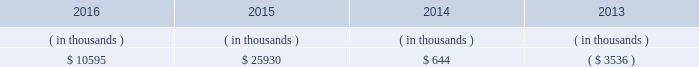Entergy mississippi , inc .
Management 2019s financial discussion and analysis entergy mississippi 2019s receivables from or ( payables to ) the money pool were as follows as of december 31 for each of the following years. .
See note 4 to the financial statements for a description of the money pool .
Entergy mississippi has four separate credit facilities in the aggregate amount of $ 102.5 million scheduled to expire may 2017 .
No borrowings were outstanding under the credit facilities as of december 31 , 2016 .
In addition , entergy mississippi is a party to an uncommitted letter of credit facility as a means to post collateral to support its obligations under miso .
As of december 31 , 2016 , a $ 7.1 million letter of credit was outstanding under entergy mississippi 2019s uncommitted letter of credit facility .
See note 4 to the financial statements for additional discussion of the credit facilities .
Entergy mississippi obtained authorizations from the ferc through october 2017 for short-term borrowings not to exceed an aggregate amount of $ 175 million at any time outstanding and long-term borrowings and security issuances .
See note 4 to the financial statements for further discussion of entergy mississippi 2019s short-term borrowing limits .
State and local rate regulation and fuel-cost recovery the rates that entergy mississippi charges for electricity significantly influence its financial position , results of operations , and liquidity .
Entergy mississippi is regulated and the rates charged to its customers are determined in regulatory proceedings .
A governmental agency , the mpsc , is primarily responsible for approval of the rates charged to customers .
Formula rate plan in june 2014 , entergy mississippi filed its first general rate case before the mpsc in almost 12 years .
The rate filing laid out entergy mississippi 2019s plans for improving reliability , modernizing the grid , maintaining its workforce , stabilizing rates , utilizing new technologies , and attracting new industry to its service territory .
Entergy mississippi requested a net increase in revenue of $ 49 million for bills rendered during calendar year 2015 , including $ 30 million resulting from new depreciation rates to update the estimated service life of assets .
In addition , the filing proposed , among other things : 1 ) realigning cost recovery of the attala and hinds power plant acquisitions from the power management rider to base rates ; 2 ) including certain miso-related revenues and expenses in the power management rider ; 3 ) power management rider changes that reflect the changes in costs and revenues that will accompany entergy mississippi 2019s withdrawal from participation in the system agreement ; and 4 ) a formula rate plan forward test year to allow for known changes in expenses and revenues for the rate effective period .
Entergy mississippi proposed maintaining the current authorized return on common equity of 10.59% ( 10.59 % ) .
In october 2014 , entergy mississippi and the mississippi public utilities staff entered into and filed joint stipulations that addressed the majority of issues in the proceeding .
The stipulations provided for : 2022 an approximate $ 16 million net increase in revenues , which reflected an agreed upon 10.07% ( 10.07 % ) return on common equity ; 2022 revision of entergy mississippi 2019s formula rate plan by providing entergy mississippi with the ability to reflect known and measurable changes to historical rate base and certain expense amounts ; resolving uncertainty around and obviating the need for an additional rate filing in connection with entergy mississippi 2019s withdrawal from participation in the system agreement ; updating depreciation rates ; and moving costs associated with the attala and hinds generating plants from the power management rider to base rates; .
The company requested a net increase in revenue for bills rendered during calendar year 2015 . what would the increase have been , in millions , without the amount reflating to the new depreciation rates? 
Computations: (49 - 30)
Answer: 19.0. 